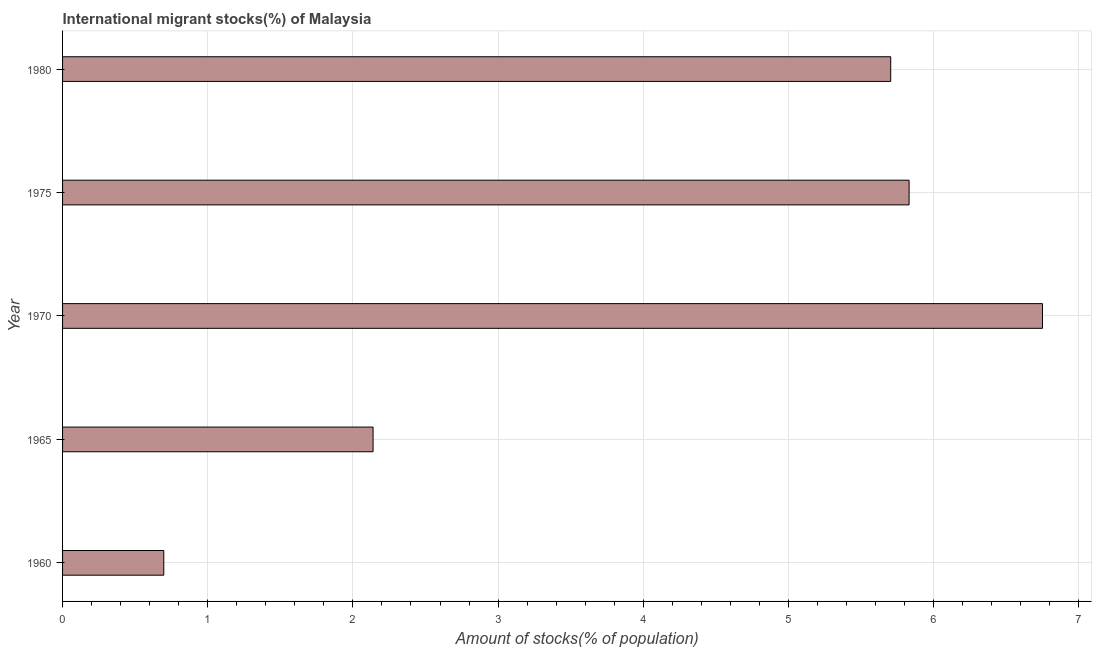Does the graph contain any zero values?
Provide a succinct answer. No. What is the title of the graph?
Give a very brief answer. International migrant stocks(%) of Malaysia. What is the label or title of the X-axis?
Keep it short and to the point. Amount of stocks(% of population). What is the label or title of the Y-axis?
Your answer should be compact. Year. What is the number of international migrant stocks in 1965?
Provide a succinct answer. 2.14. Across all years, what is the maximum number of international migrant stocks?
Provide a succinct answer. 6.75. Across all years, what is the minimum number of international migrant stocks?
Make the answer very short. 0.7. In which year was the number of international migrant stocks maximum?
Keep it short and to the point. 1970. In which year was the number of international migrant stocks minimum?
Ensure brevity in your answer.  1960. What is the sum of the number of international migrant stocks?
Offer a terse response. 21.12. What is the difference between the number of international migrant stocks in 1960 and 1980?
Ensure brevity in your answer.  -5.01. What is the average number of international migrant stocks per year?
Offer a very short reply. 4.22. What is the median number of international migrant stocks?
Offer a very short reply. 5.7. In how many years, is the number of international migrant stocks greater than 4.2 %?
Ensure brevity in your answer.  3. What is the ratio of the number of international migrant stocks in 1965 to that in 1970?
Provide a succinct answer. 0.32. Is the number of international migrant stocks in 1960 less than that in 1975?
Your answer should be very brief. Yes. What is the difference between the highest and the second highest number of international migrant stocks?
Keep it short and to the point. 0.92. Is the sum of the number of international migrant stocks in 1960 and 1970 greater than the maximum number of international migrant stocks across all years?
Your answer should be compact. Yes. What is the difference between the highest and the lowest number of international migrant stocks?
Provide a short and direct response. 6.05. How many bars are there?
Offer a terse response. 5. Are all the bars in the graph horizontal?
Give a very brief answer. Yes. How many years are there in the graph?
Make the answer very short. 5. Are the values on the major ticks of X-axis written in scientific E-notation?
Your answer should be very brief. No. What is the Amount of stocks(% of population) of 1960?
Provide a succinct answer. 0.7. What is the Amount of stocks(% of population) in 1965?
Keep it short and to the point. 2.14. What is the Amount of stocks(% of population) in 1970?
Ensure brevity in your answer.  6.75. What is the Amount of stocks(% of population) in 1975?
Your answer should be compact. 5.83. What is the Amount of stocks(% of population) of 1980?
Your answer should be very brief. 5.7. What is the difference between the Amount of stocks(% of population) in 1960 and 1965?
Provide a succinct answer. -1.44. What is the difference between the Amount of stocks(% of population) in 1960 and 1970?
Your response must be concise. -6.05. What is the difference between the Amount of stocks(% of population) in 1960 and 1975?
Ensure brevity in your answer.  -5.13. What is the difference between the Amount of stocks(% of population) in 1960 and 1980?
Your answer should be very brief. -5.01. What is the difference between the Amount of stocks(% of population) in 1965 and 1970?
Give a very brief answer. -4.61. What is the difference between the Amount of stocks(% of population) in 1965 and 1975?
Keep it short and to the point. -3.69. What is the difference between the Amount of stocks(% of population) in 1965 and 1980?
Your response must be concise. -3.57. What is the difference between the Amount of stocks(% of population) in 1970 and 1975?
Offer a terse response. 0.92. What is the difference between the Amount of stocks(% of population) in 1970 and 1980?
Your answer should be very brief. 1.05. What is the difference between the Amount of stocks(% of population) in 1975 and 1980?
Ensure brevity in your answer.  0.13. What is the ratio of the Amount of stocks(% of population) in 1960 to that in 1965?
Offer a terse response. 0.33. What is the ratio of the Amount of stocks(% of population) in 1960 to that in 1970?
Your answer should be compact. 0.1. What is the ratio of the Amount of stocks(% of population) in 1960 to that in 1975?
Offer a terse response. 0.12. What is the ratio of the Amount of stocks(% of population) in 1960 to that in 1980?
Offer a very short reply. 0.12. What is the ratio of the Amount of stocks(% of population) in 1965 to that in 1970?
Your answer should be compact. 0.32. What is the ratio of the Amount of stocks(% of population) in 1965 to that in 1975?
Your response must be concise. 0.37. What is the ratio of the Amount of stocks(% of population) in 1970 to that in 1975?
Make the answer very short. 1.16. What is the ratio of the Amount of stocks(% of population) in 1970 to that in 1980?
Make the answer very short. 1.18. What is the ratio of the Amount of stocks(% of population) in 1975 to that in 1980?
Your answer should be compact. 1.02. 